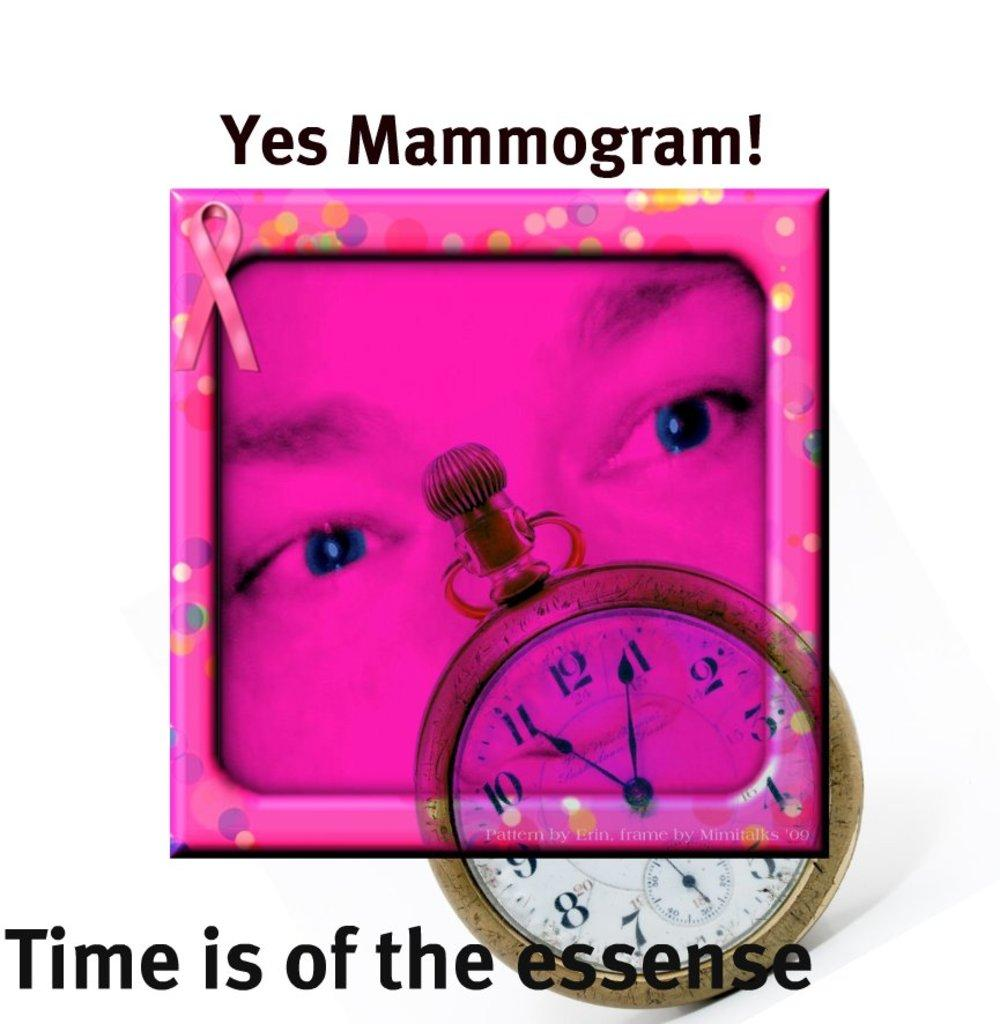Provide a one-sentence caption for the provided image. A purple square with a face on it , with it says "Yes mammogram!" above it. 